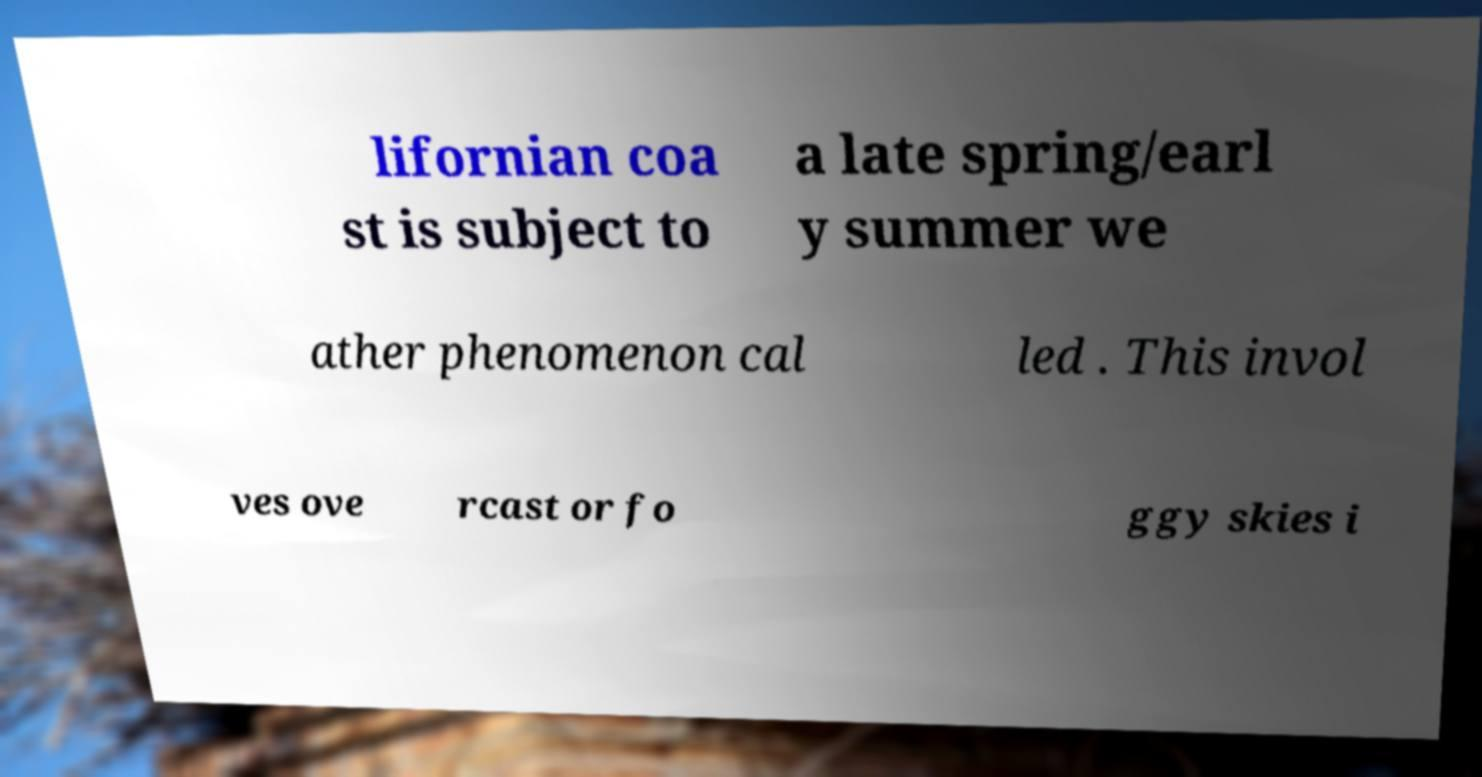For documentation purposes, I need the text within this image transcribed. Could you provide that? lifornian coa st is subject to a late spring/earl y summer we ather phenomenon cal led . This invol ves ove rcast or fo ggy skies i 